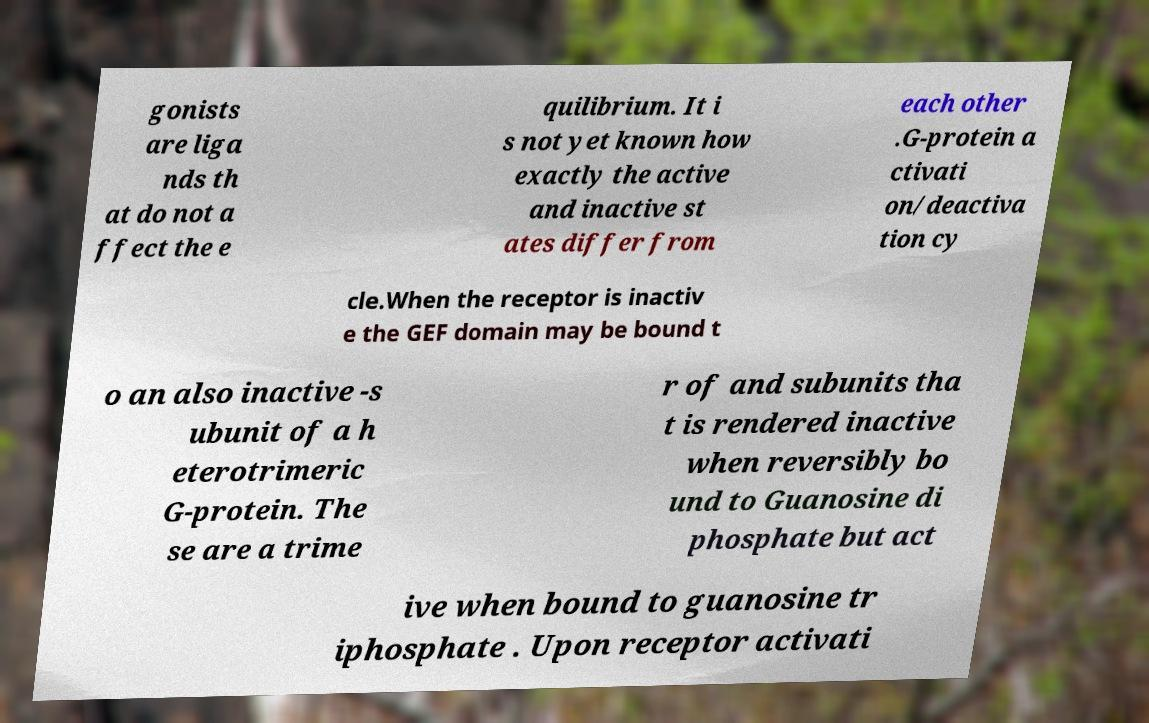Please identify and transcribe the text found in this image. gonists are liga nds th at do not a ffect the e quilibrium. It i s not yet known how exactly the active and inactive st ates differ from each other .G-protein a ctivati on/deactiva tion cy cle.When the receptor is inactiv e the GEF domain may be bound t o an also inactive -s ubunit of a h eterotrimeric G-protein. The se are a trime r of and subunits tha t is rendered inactive when reversibly bo und to Guanosine di phosphate but act ive when bound to guanosine tr iphosphate . Upon receptor activati 